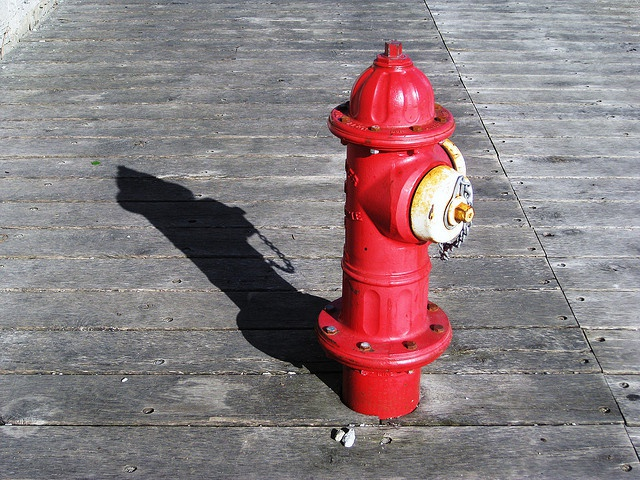Describe the objects in this image and their specific colors. I can see a fire hydrant in lightgray, red, salmon, and brown tones in this image. 